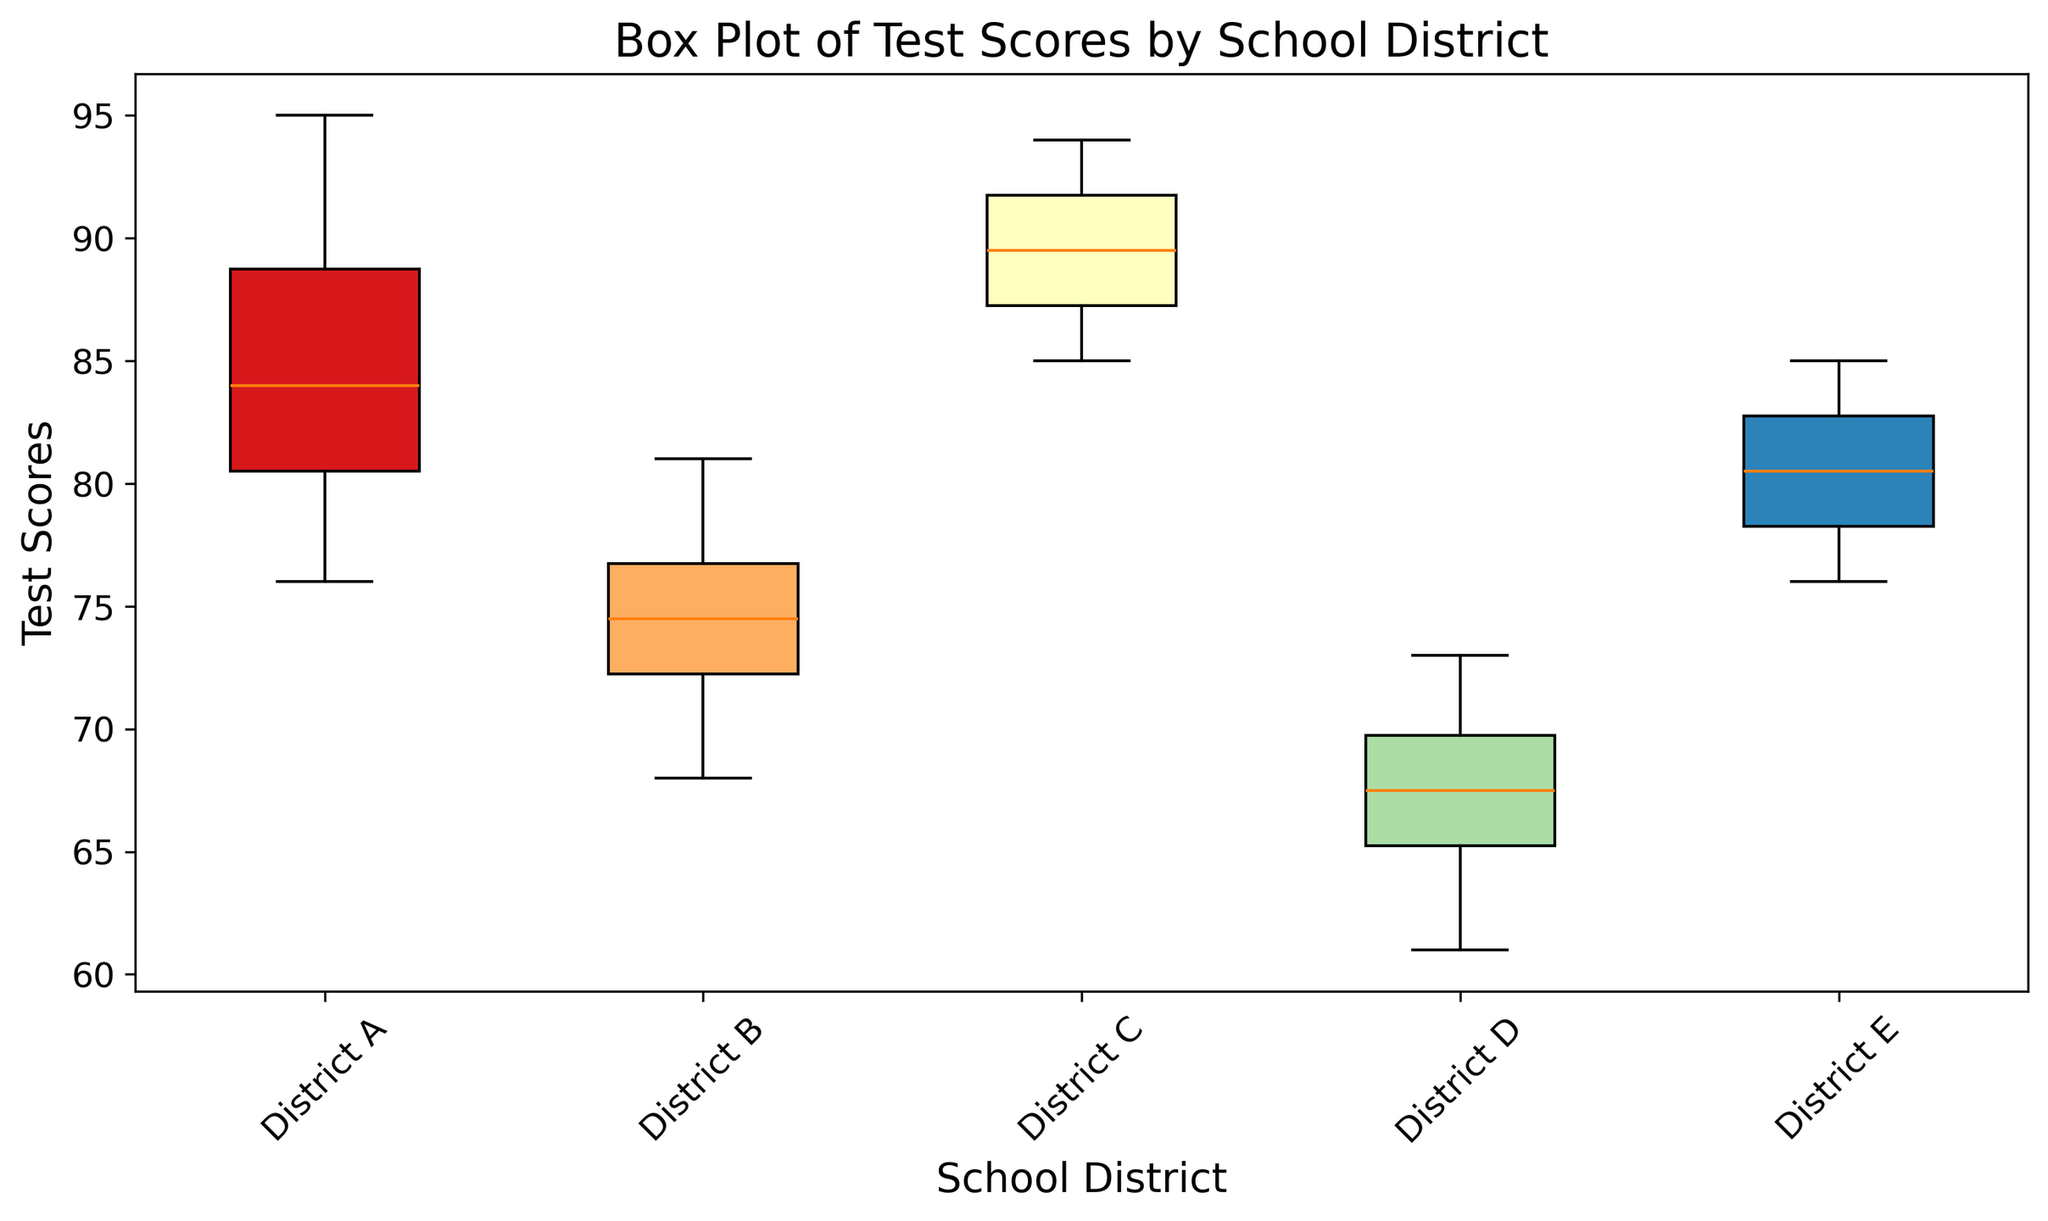Which school district has the highest median test score? To determine the district with the highest median test score, look at the central line within the boxes representing the median for each district. The highest median is the one located the furthest up on the y-axis.
Answer: District C Which school district has the widest range of test scores? The range of test scores in each district is represented by the length of the box and the whiskers. The widest range is where the difference between the maximum and minimum values (whiskers) is the largest.
Answer: District D Between District A and District E, which one has the higher upper quartile value? The upper quartile (75th percentile) is represented by the top edge of the box. Compare the top edges of District A's and District E's boxes to determine which is higher.
Answer: District A Which school district has the smallest interquartile range (IQR)? The interquartile range (IQR) is the difference between the upper quartile (top of the box) and the lower quartile (bottom of the box). The smallest IQR is the shortest box.
Answer: District B What is the median test score for District D? The median test score is indicated by the line inside the box for District D. Identify the value on the y-axis where this line is positioned.
Answer: 67 How does the median test score of District A compare to the median test score of District B? Compare the position of the median lines (central lines in the boxes) of District A and District B. The district with the higher positioned median line has the higher median test score.
Answer: District A's median is higher than District B's Which district has the lowest minimum test score? The minimum test score is represented by the bottom whisker for each district. The lowest end of the whisker across all boxes identifies the district with the lowest minimum score.
Answer: District D Compare the upper whiskers of Districts C and D. Which has the higher value? The upper whisker represents the maximum value (excluding outliers). Compare the top ends of the whiskers for Districts C and D to find the district with the higher maximum value.
Answer: District C In terms of the interquartile range (IQR), how does District E compare with District B? Calculate the IQR for both districts by finding the height difference between the top and bottom edges of the boxes. District E's box height is larger or smaller than District B's box height.
Answer: District E has a larger IQR than District B Between District A and District D, which one has a more symmetric distribution of test scores? Symmetry in a box plot is indicated by the median being roughly centered within the box and the whiskers being approximately equally long. Assess the symmetry by observing the box and whiskers of District A and District D.
Answer: District A 